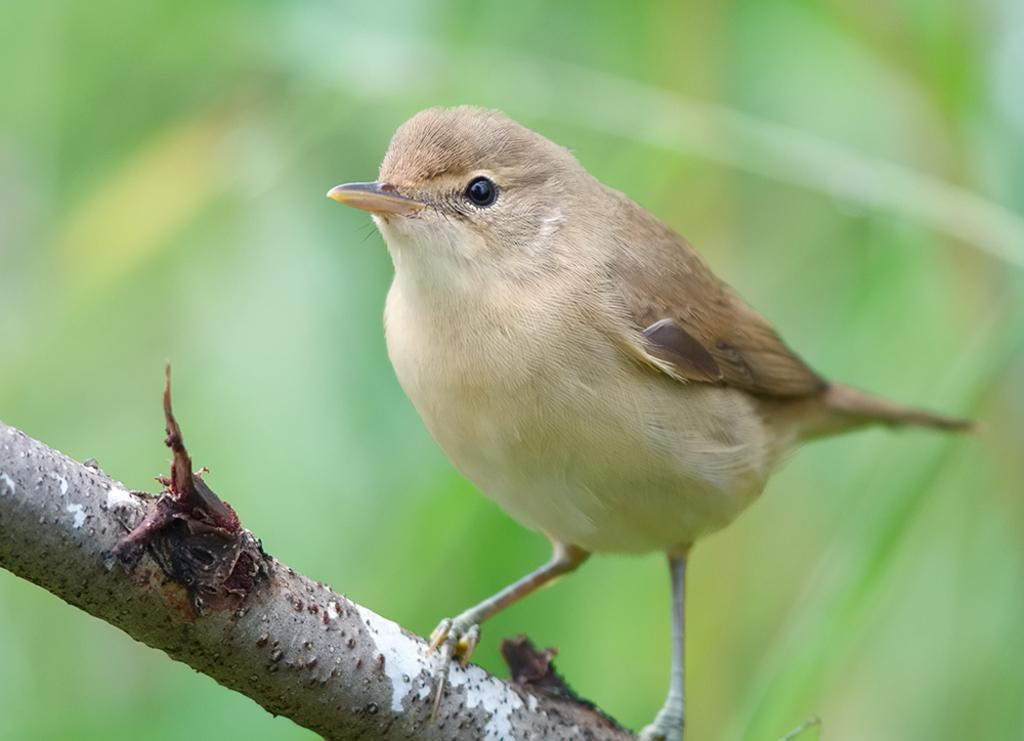What type of animal is in the image? There is a bird in the image. Where is the bird located? The bird is on a branch. What can be seen behind the bird? There are leaves visible behind the bird. What type of dress is the bird wearing in the image? There is no dress present in the image, as birds do not wear clothing. 